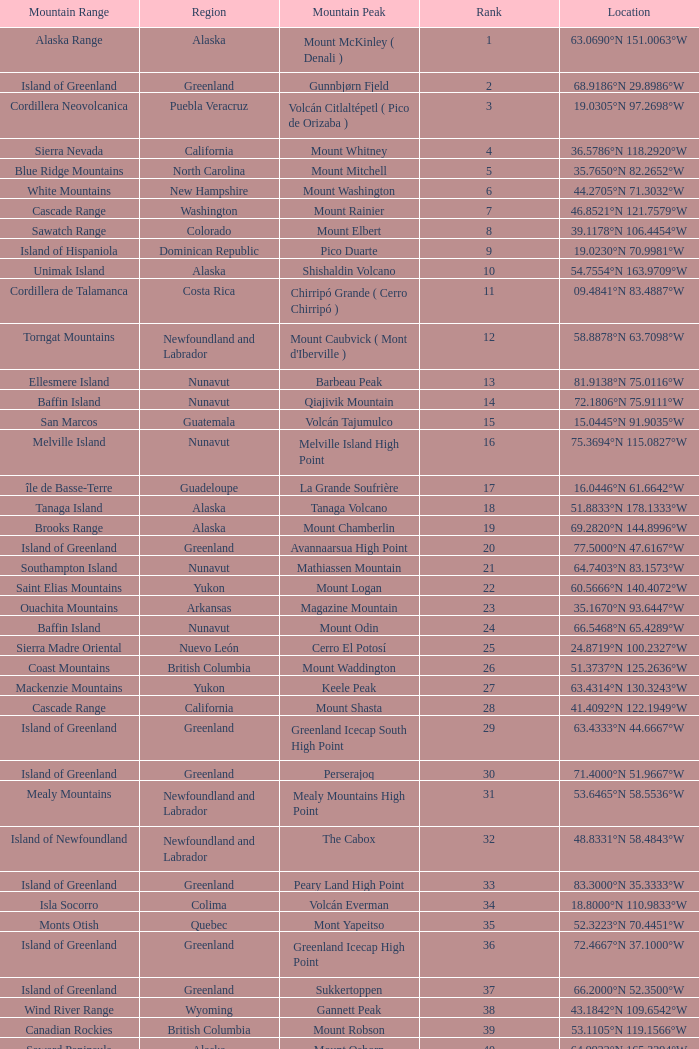Name the Mountain Peak which has a Rank of 62? Cerro Nube ( Quie Yelaag ). 